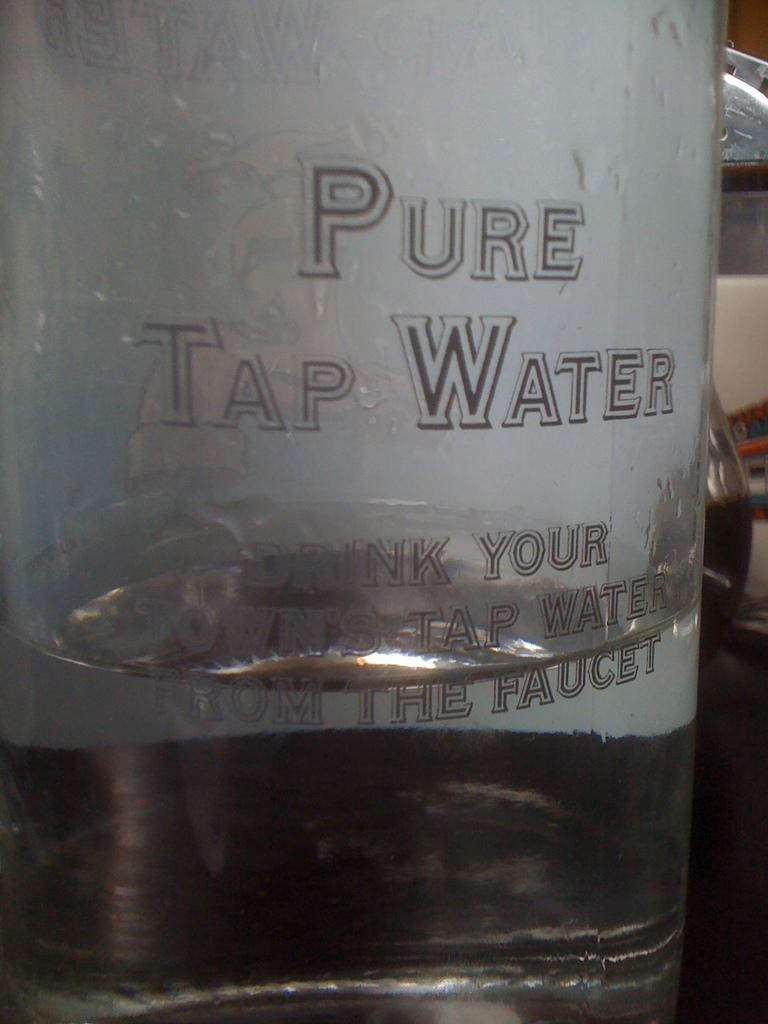Where does the water come from?
Make the answer very short. Tap. 